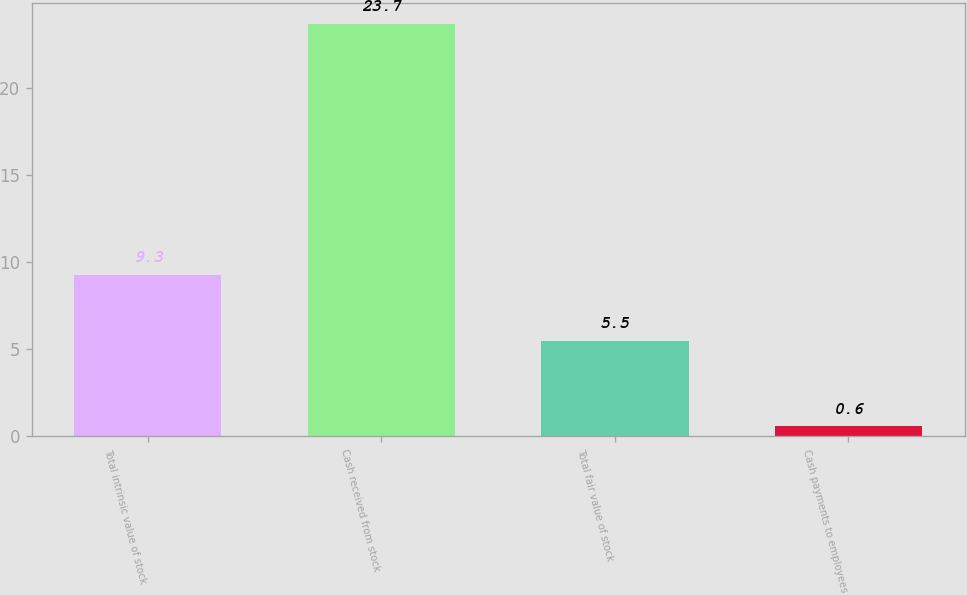Convert chart. <chart><loc_0><loc_0><loc_500><loc_500><bar_chart><fcel>Total intrinsic value of stock<fcel>Cash received from stock<fcel>Total fair value of stock<fcel>Cash payments to employees<nl><fcel>9.3<fcel>23.7<fcel>5.5<fcel>0.6<nl></chart> 